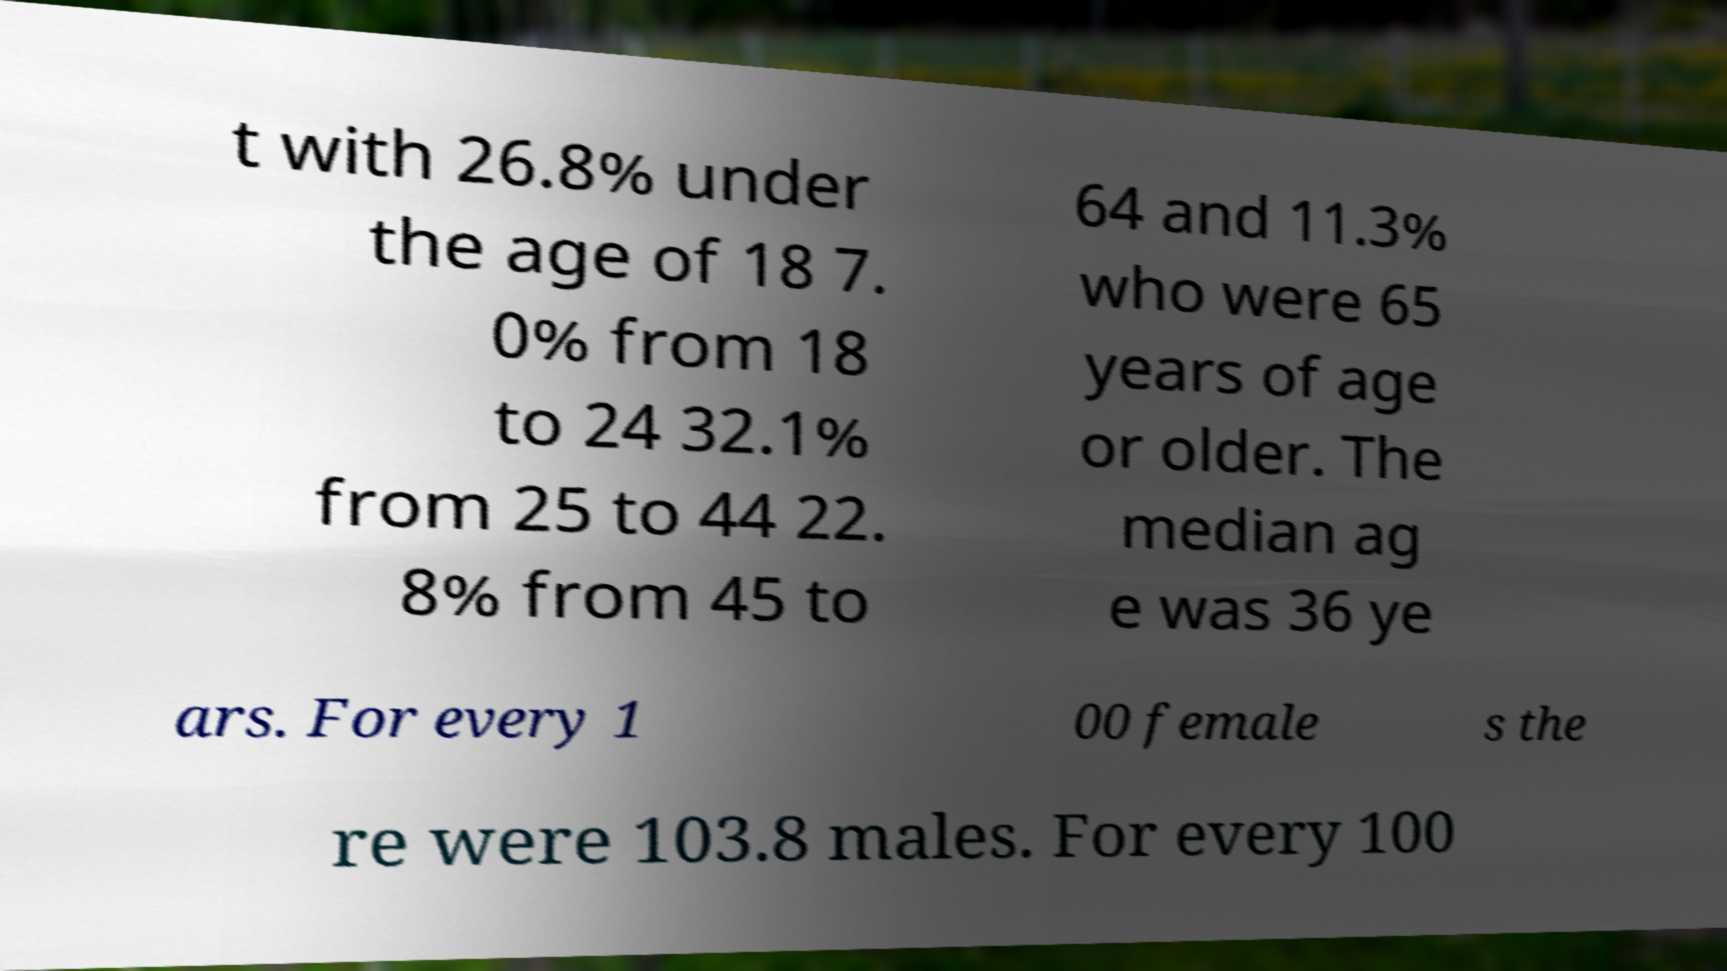Can you read and provide the text displayed in the image?This photo seems to have some interesting text. Can you extract and type it out for me? t with 26.8% under the age of 18 7. 0% from 18 to 24 32.1% from 25 to 44 22. 8% from 45 to 64 and 11.3% who were 65 years of age or older. The median ag e was 36 ye ars. For every 1 00 female s the re were 103.8 males. For every 100 